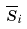Convert formula to latex. <formula><loc_0><loc_0><loc_500><loc_500>\overline { S } _ { i }</formula> 